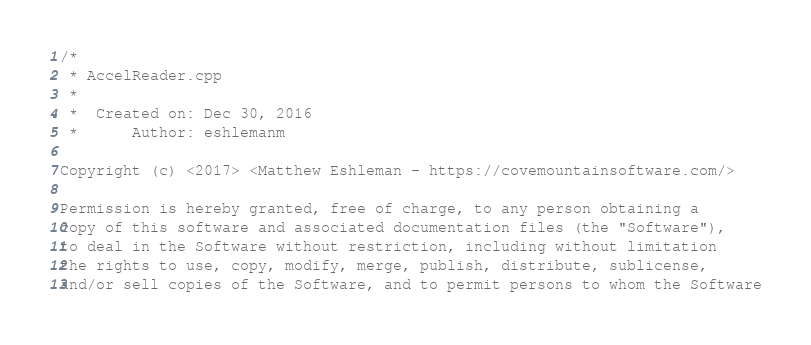Convert code to text. <code><loc_0><loc_0><loc_500><loc_500><_C++_>/*
 * AccelReader.cpp
 *
 *  Created on: Dec 30, 2016
 *      Author: eshlemanm

Copyright (c) <2017> <Matthew Eshleman - https://covemountainsoftware.com/>

Permission is hereby granted, free of charge, to any person obtaining a
copy of this software and associated documentation files (the "Software"),
to deal in the Software without restriction, including without limitation
the rights to use, copy, modify, merge, publish, distribute, sublicense,
and/or sell copies of the Software, and to permit persons to whom the Software</code> 